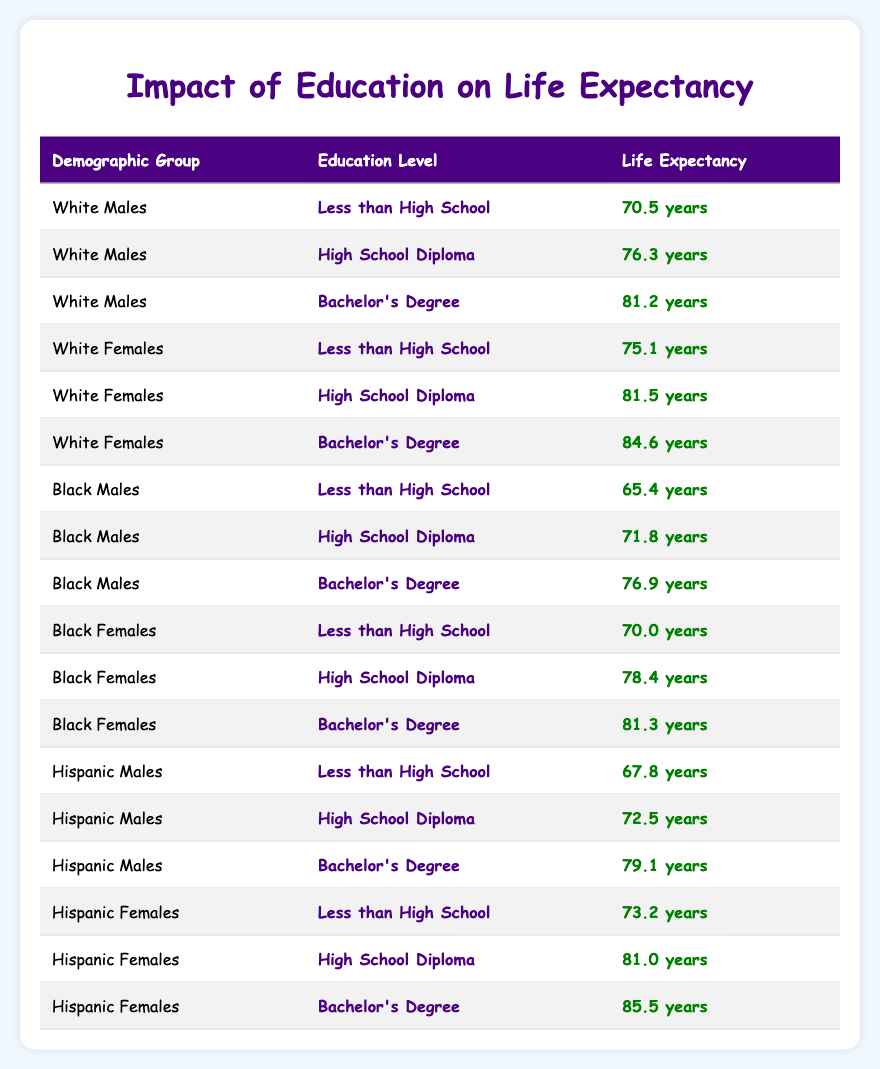What is the life expectancy of White Males with a Bachelor's Degree? According to the table, the life expectancy for White Males with a Bachelor's Degree is directly listed as 81.2 years.
Answer: 81.2 years What is the difference in life expectancy between Black Females with a High School Diploma and those with a Bachelor's Degree? The life expectancy for Black Females with a High School Diploma is 78.4 years, and with a Bachelor's Degree, it is 81.3 years. The difference is calculated by subtracting: 81.3 - 78.4 = 2.9 years.
Answer: 2.9 years Is the life expectancy of Hispanic Males with less than a High School education higher than that of Black Males with a High School Diploma? The life expectancy for Hispanic Males with less than High School is 67.8 years, while for Black Males with a High School Diploma it is 71.8 years. Since 67.8 is less than 71.8, the statement is false.
Answer: No What is the average life expectancy for White Females across all education levels listed in the table? For White Females, the listed life expectancies are 75.1, 81.5, and 84.6 years. First, we sum these values: 75.1 + 81.5 + 84.6 = 241.2 years. Next, we divide by the number of education levels, which is 3: 241.2 / 3 = 80.4 years.
Answer: 80.4 years Which demographic group has the lowest life expectancy for people with less than a High School education? Looking at the table, the life expectancy for Black Males with less than High School is 65.4 years, which is the lowest compared to White Males (70.5) and Hispanic Males (67.8). Therefore, Black Males have the lowest life expectancy with this education level.
Answer: Black Males What is the life expectancy of Hispanic Females with a Bachelor's Degree? The table states that the life expectancy for Hispanic Females with a Bachelor's Degree is 85.5 years, as listed directly under that category.
Answer: 85.5 years What is the life expectancy of the demographic group with the highest life expectancy for a High School Diploma? Among the demographic groups with a High School Diploma, the life expectancies are: White Females (81.5), Black Males (71.8), and Hispanic Males (72.5). The highest is 81.5 years, belonging to White Females.
Answer: White Females Is the life expectancy of Black Females with a Bachelor's Degree greater than the life expectancy of Hispanic Males with a High School Diploma? The life expectancy of Black Females with a Bachelor's Degree is 81.3 years, while for Hispanic Males with a High School Diploma it is 72.5 years. Since 81.3 is greater than 72.5, the answer is yes.
Answer: Yes 